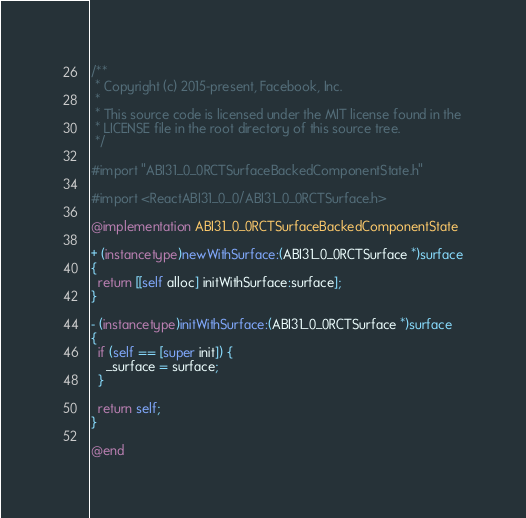Convert code to text. <code><loc_0><loc_0><loc_500><loc_500><_ObjectiveC_>/**
 * Copyright (c) 2015-present, Facebook, Inc.
 *
 * This source code is licensed under the MIT license found in the
 * LICENSE file in the root directory of this source tree.
 */

#import "ABI31_0_0RCTSurfaceBackedComponentState.h"

#import <ReactABI31_0_0/ABI31_0_0RCTSurface.h>

@implementation ABI31_0_0RCTSurfaceBackedComponentState

+ (instancetype)newWithSurface:(ABI31_0_0RCTSurface *)surface
{
  return [[self alloc] initWithSurface:surface];
}

- (instancetype)initWithSurface:(ABI31_0_0RCTSurface *)surface
{
  if (self == [super init]) {
    _surface = surface;
  }

  return self;
}

@end
</code> 